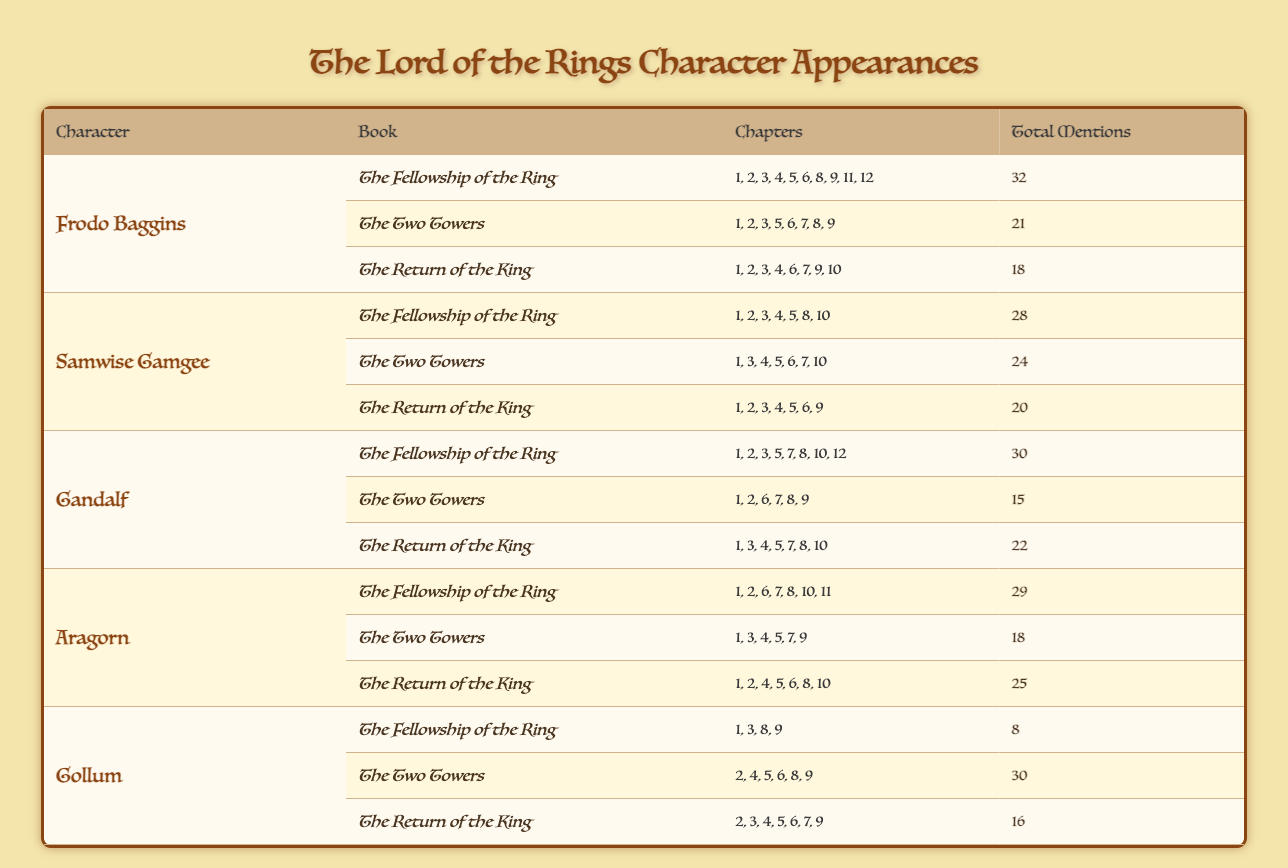What is the total number of mentions for Samwise Gamgee in "The Fellowship of the Ring"? Samwise Gamgee has 28 total mentions in "The Fellowship of the Ring," which is listed directly in the table under the respective book and character.
Answer: 28 Which character has the highest total mentions in "The Two Towers"? In "The Two Towers," Gollum has the highest total mentions with 30 listed under his appearances for that book.
Answer: Gollum What is the total number of chapters that Frodo Baggins appears in across all three books? Frodo Baggins appears in 10 chapters in "The Fellowship of the Ring," 8 chapters in "The Two Towers," and 8 chapters in "The Return of the King." Summing up these values gives 10 + 8 + 8 = 26 chapters total.
Answer: 26 Did Gandalf appear in more chapters in "The Fellowship of the Ring" than in "The Two Towers"? Gandalf appears in 8 chapters in "The Fellowship of the Ring," and in 6 chapters in "The Two Towers." Since 8 is greater than 6, the statement is true.
Answer: Yes What is the average number of mentions for Aragorn across all books? To find the average, first total Aragorn's mentions: 29 in "The Fellowship of the Ring," 18 in "The Two Towers," and 25 in "The Return of the King," which adds up to 72. There are 3 books, so the average is 72 divided by 3, which equals 24.
Answer: 24 Which book has the least mentions for Gollum? Gollum has 8 mentions in "The Fellowship of the Ring," 30 in "The Two Towers," and 16 in "The Return of the King." The book with the least mentions is "The Fellowship of the Ring," as 8 is the lowest value.
Answer: The Fellowship of the Ring What is the sum of total mentions for all characters in "The Return of the King"? Adding the total mentions from "The Return of the King" gives: Frodo (18), Samwise (20), Gandalf (22), Aragorn (25), and Gollum (16). Summing these, we get 18 + 20 + 22 + 25 + 16 = 101 mentions in total for that book.
Answer: 101 Did Frodo Baggins have a higher total number of mentions than Aragorn across all books? Frodo's total mentions are 32 (Fellowship) + 21 (Two Towers) + 18 (Return) = 71. Aragorn's total mentions are 29 + 18 + 25 = 72. Since 71 is less than 72, the statement is false.
Answer: No 